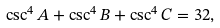Convert formula to latex. <formula><loc_0><loc_0><loc_500><loc_500>\csc ^ { 4 } A + \csc ^ { 4 } B + \csc ^ { 4 } C = 3 2 ,</formula> 